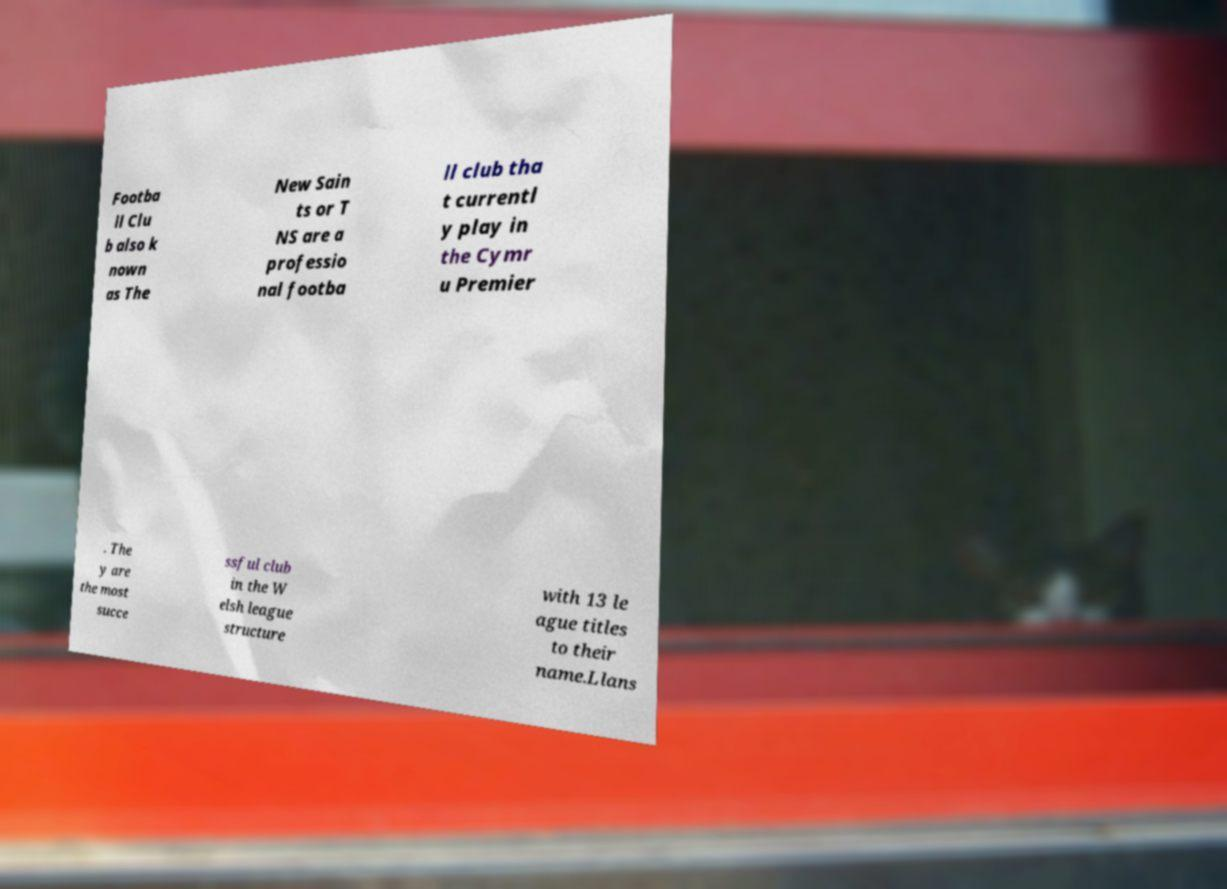I need the written content from this picture converted into text. Can you do that? Footba ll Clu b also k nown as The New Sain ts or T NS are a professio nal footba ll club tha t currentl y play in the Cymr u Premier . The y are the most succe ssful club in the W elsh league structure with 13 le ague titles to their name.Llans 